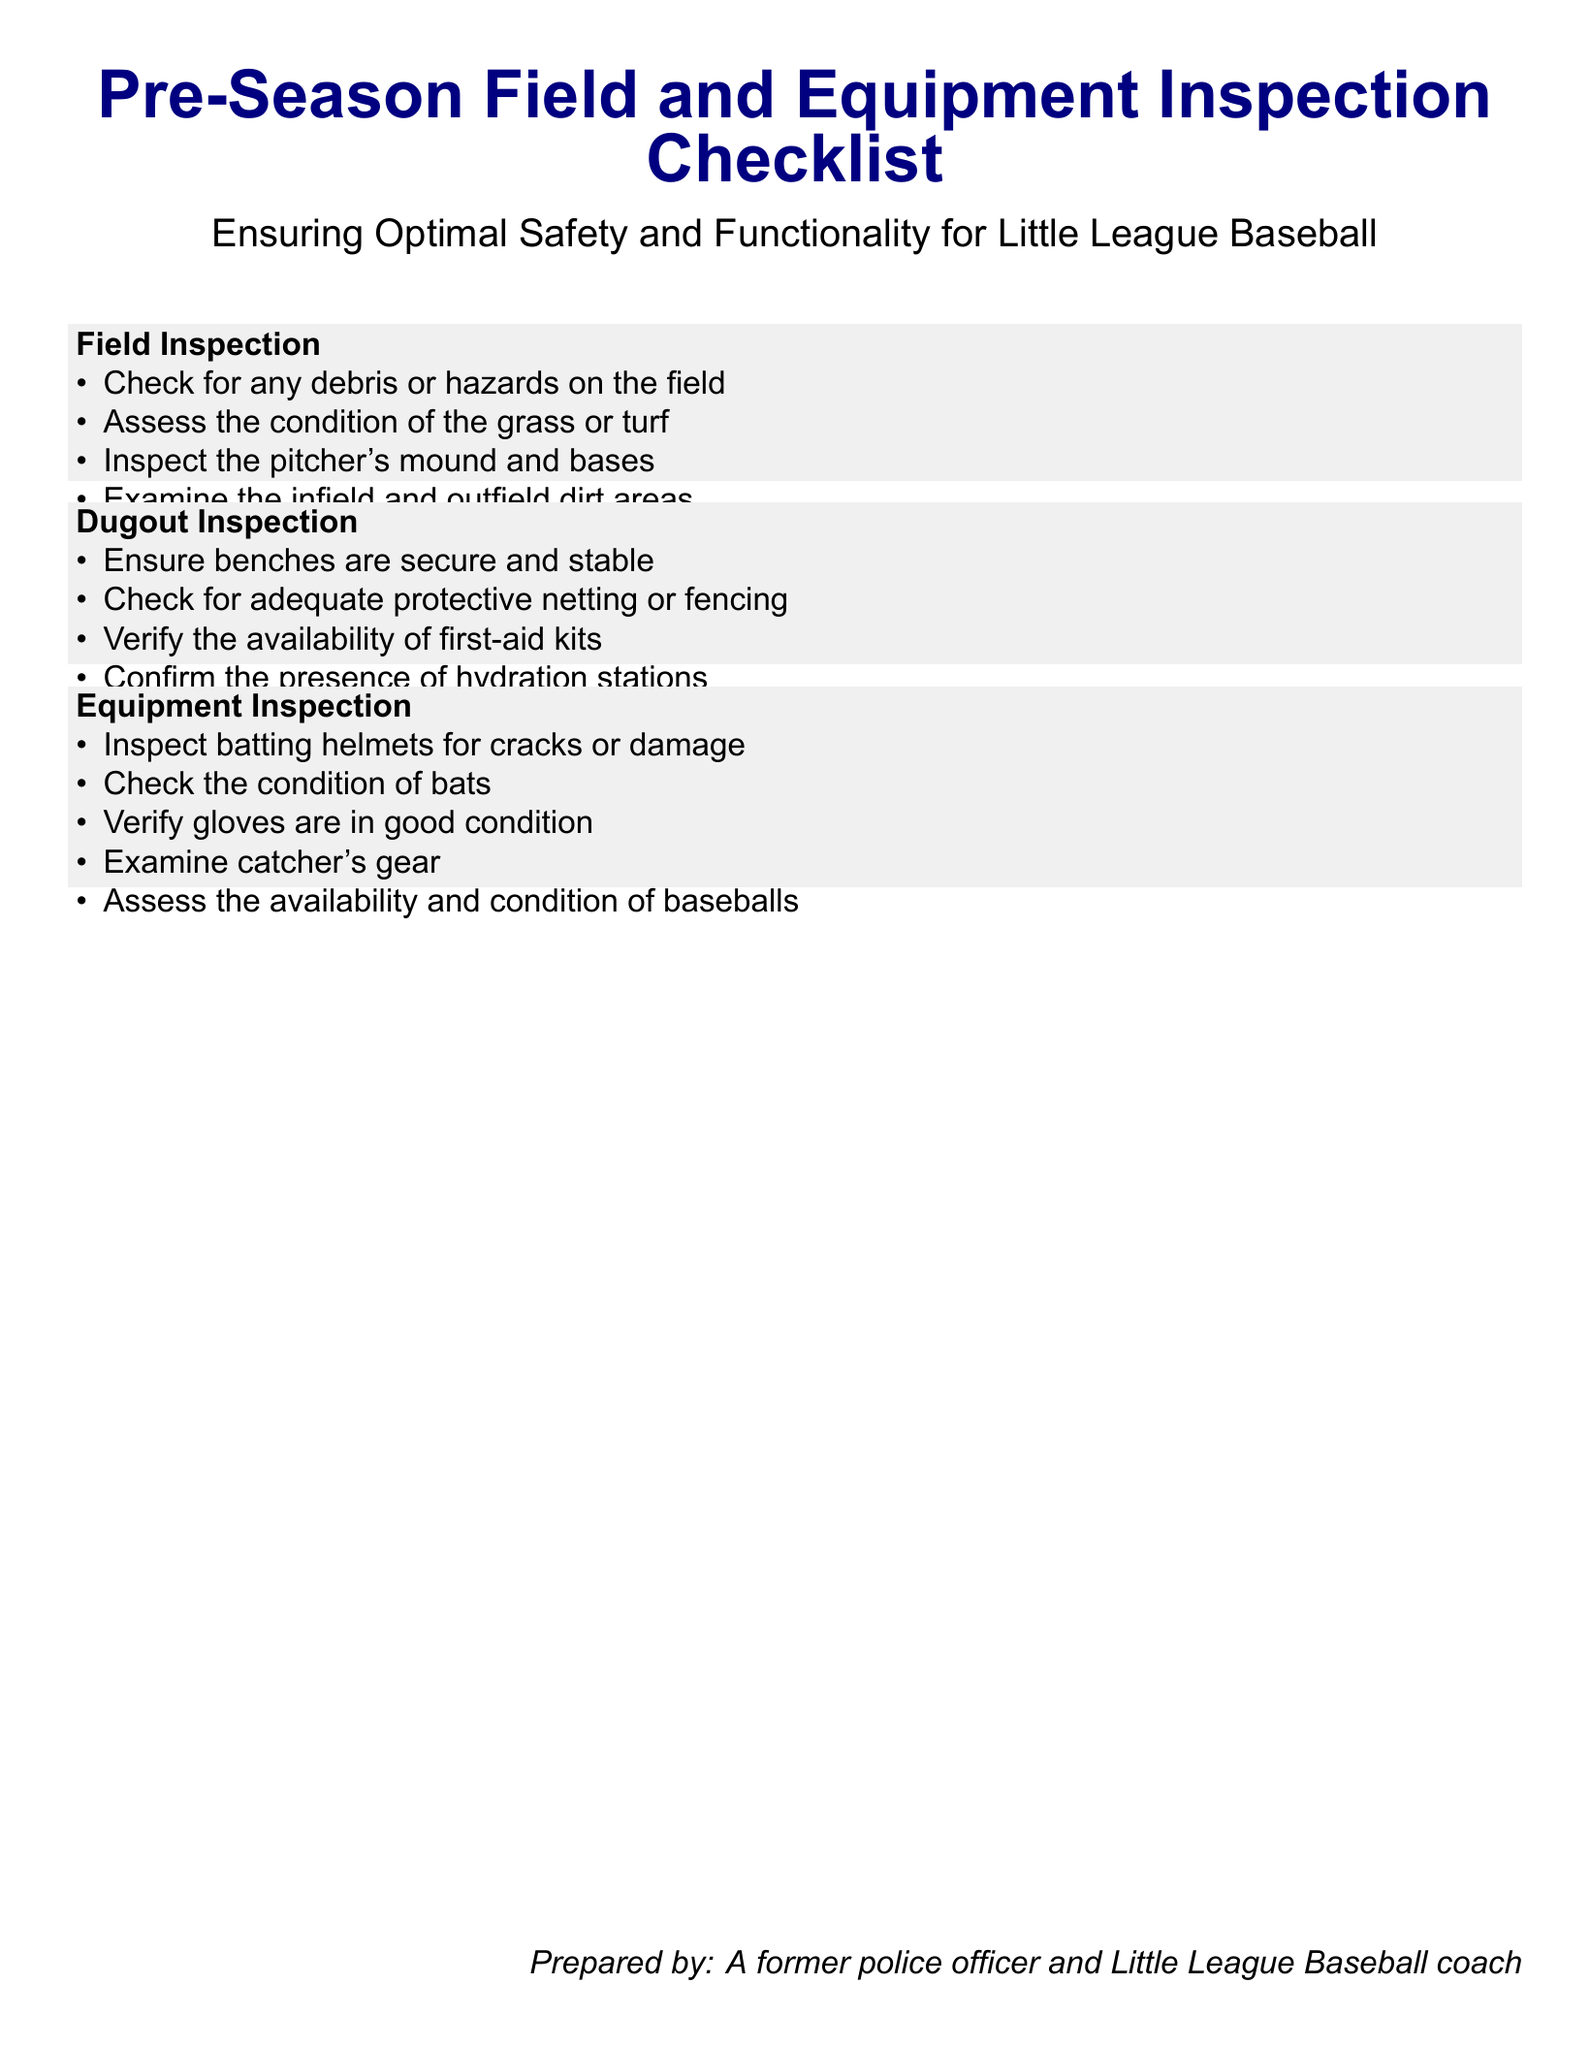What is the title of the document? The title is stated in a large font at the beginning of the document, clearly indicating its purpose and focus.
Answer: Pre-Season Field and Equipment Inspection Checklist How many items are listed under Field Inspection? The document provides a specific number of checklist items under the Field Inspection section, which can be counted directly from the list.
Answer: 4 What is one of the conditions checked for in the Dugout Inspection? The document lists specific checks for the Dugout Inspection, which can be referenced directly.
Answer: Protective netting What type of gear is examined in the Equipment Inspection? The document specifies different types of equipment that are inspected, highlighting the focus on safety and functionality.
Answer: Catcher's gear What color is used for the section headings? The document uses a color theme throughout, where the section headings are specifically colored.
Answer: Navy blue Which group is the document prepared for? The main subject of the document clearly indicates the target audience, as seen in the title and context of the checklist.
Answer: Little League Baseball What is one of the items checked for in the Equipment Inspection? The document includes specific items under the Equipment Inspection category, which can be referenced.
Answer: Bats How is first-aid gear verified in the Dugout Inspection? The checklist describes specific checks done in the Dugout Inspection, including first-aid gear.
Answer: Availability What provides water to the players according to the checklist? The document mentions specific facilities available for players, which can be identified directly.
Answer: Hydration stations 